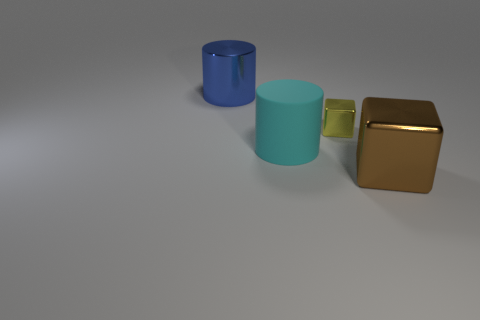Is there any indication of the light source in the image? Yes, the shadows of the objects suggest that the light source is coming from the upper left side of the image. It is casting soft shadows to the lower right side of each object, indicating the angle and direction of illumination. 